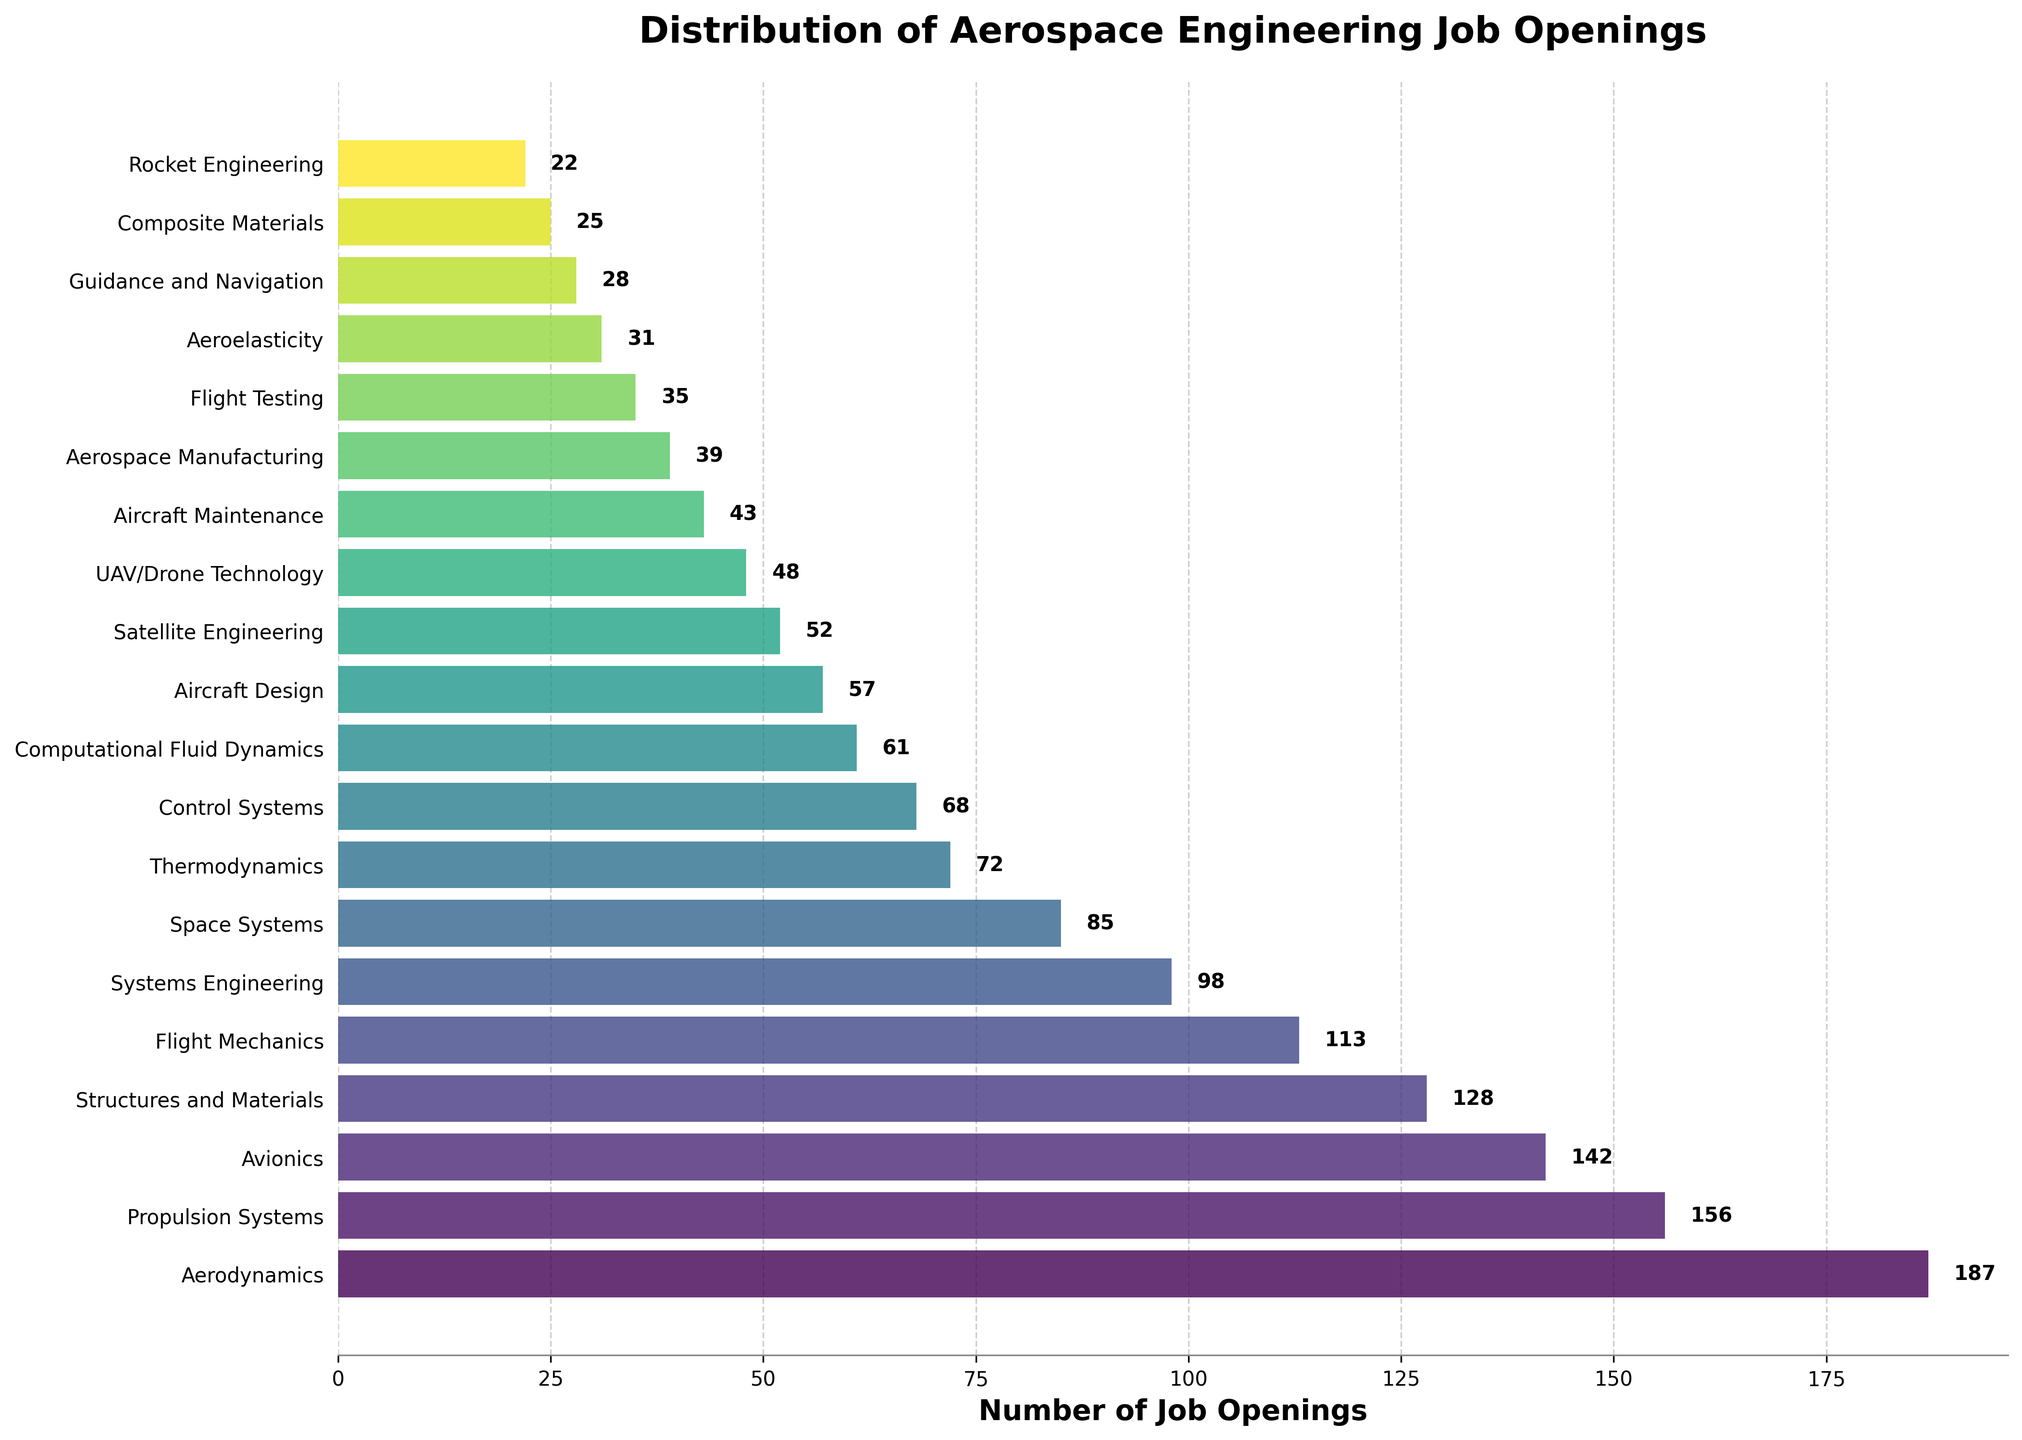Which specialization has the highest number of job openings? Look for the tallest bar or the bar that extends the farthest to the right. The specialization with the highest number on the x-axis is Aerodynamics with 187 job openings.
Answer: Aerodynamics Which specializations have fewer than 50 job openings? Check for bars that extend to the left of the 50 mark on the x-axis. The specializations with fewer than 50 job openings are Satellite Engineering, UAV/Drone Technology, Aircraft Maintenance, Aerospace Manufacturing, Flight Testing, Aeroelasticity, Guidance and Navigation, Composite Materials, and Rocket Engineering.
Answer: Satellite Engineering, UAV/Drone Technology, Aircraft Maintenance, Aerospace Manufacturing, Flight Testing, Aeroelasticity, Guidance and Navigation, Composite Materials, Rocket Engineering How many more job openings are there in Propulsion Systems compared to Control Systems? Identify the bars for Propulsion Systems and Control Systems, check their lengths on the x-axis, and find the difference. Propulsion Systems have 156 job openings and Control Systems have 68 job openings. The difference is 156 - 68 = 88.
Answer: 88 What is the average number of job openings among the top three specializations? Identify the top three specializations (Aerodynamics, Propulsion Systems, Avionics), sum their job openings (187 + 156 + 142), and divide by 3. The sum is 485, and the average is 485 / 3 = 161.67.
Answer: 161.67 Which specialization has the lowest number of job openings, and how many are there? Look for the shortest bar or the bar that ends closest to the left side of the graph. The specialization with the fewest job openings is Rocket Engineering with 22 openings.
Answer: Rocket Engineering, 22 How many specializations have job openings between 100 and 150? Identify bars whose lengths fall between the 100 and 150 marks on the x-axis. The specializations that meet this criterion are Avionics (142), Structures and Materials (128), and Flight Mechanics (113). Thus, there are three such specializations.
Answer: 3 What is the total number of job openings for the specializations related to aircraft (Aircraft Design, Aircraft Maintenance, and Aerodynamics)? Sum the job openings for Aircraft Design, Aircraft Maintenance, and Aerodynamics. These are 57, 43, and 187 respectively. The total is 57 + 43 + 187 = 287.
Answer: 287 Compare the job openings in Systems Engineering and Space Systems. Which one has more and by how much? Identify the bars for Systems Engineering and Space Systems, observe their lengths, and find the difference. Systems Engineering has 98 job openings whereas Space Systems has 85. The difference is 98 - 85 = 13.
Answer: Systems Engineering, 13 What is the combined number of job openings for the bottom five specializations? Identify the bars for the bottom five specializations (Composite Materials, Rocket Engineering, Guidance and Navigation, Aeroelasticity, Flight Testing), sum their job openings (25, 22, 28, 31, 35). The total is 25 + 22 + 28 + 31 + 35 = 141.
Answer: 141 Which specialization with a turquoise-like color bar has the closest number of job openings to the average across all specializations? First, estimate the color associated with turquoise in the color gradient. Then look for the bar in that color and see which specialization it represents. Next, determine the average number of job openings across all specializations. The average is the sum of all job openings (1346) divided by the number of specializations (20), yielding 67.3. Comparing, the Flight Mechanics bar with 113 job openings appears uses a color resembling turquoise.
Answer: Flight Mechanics 